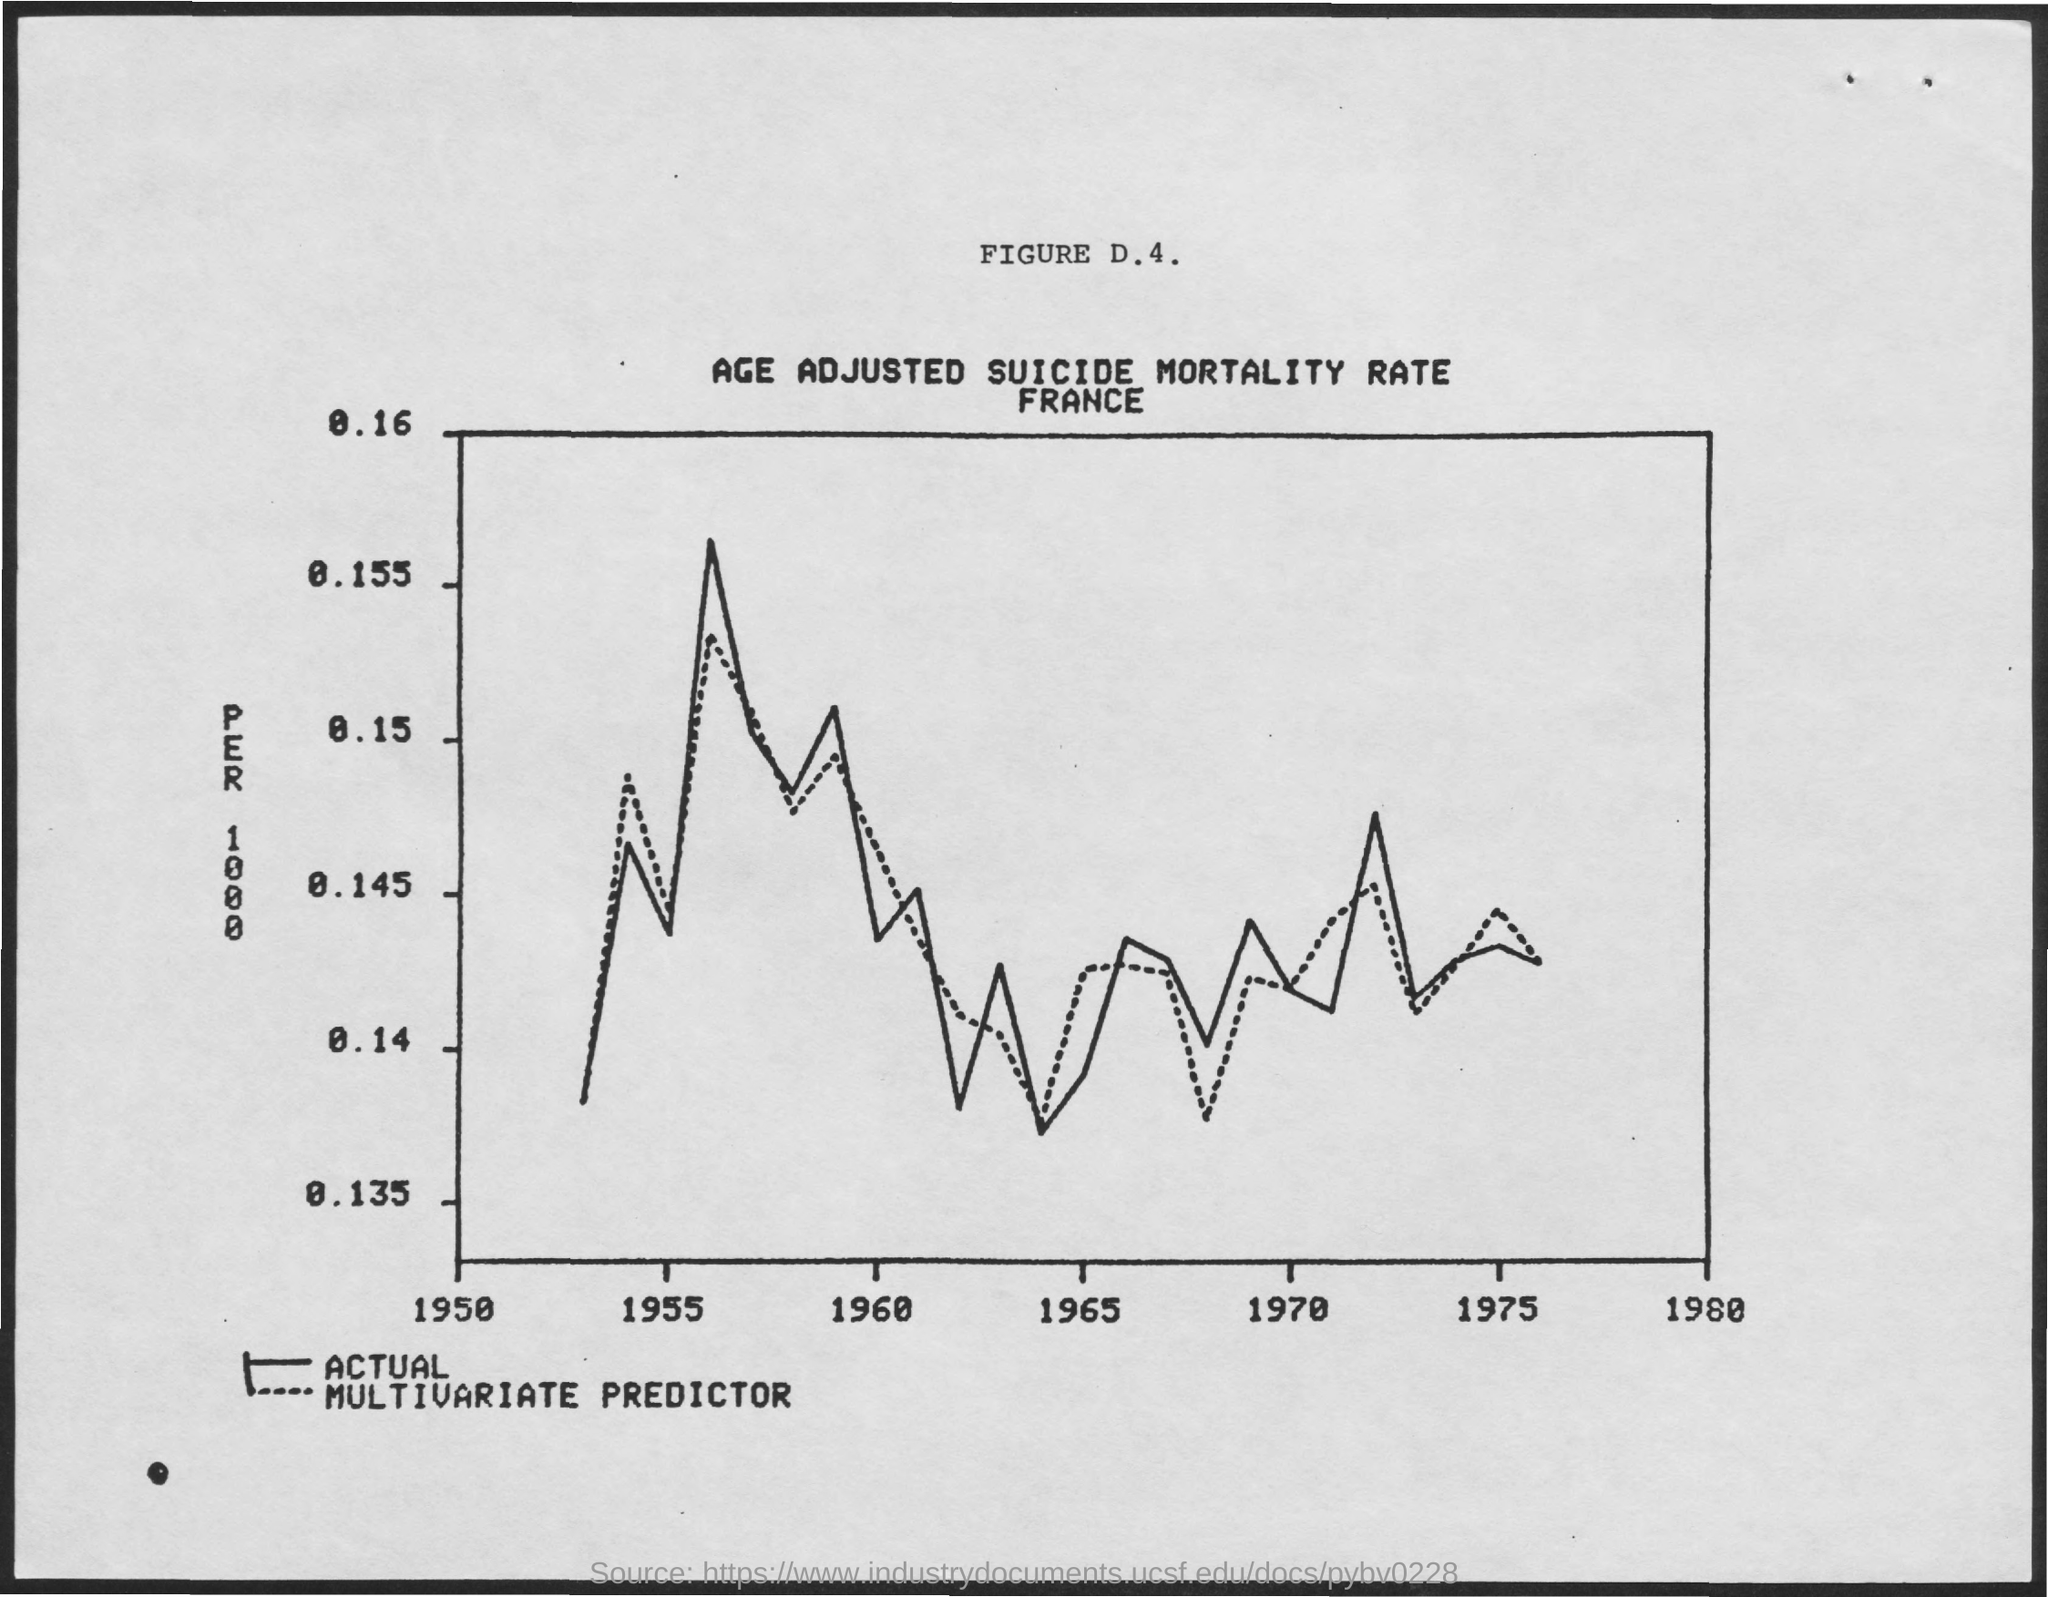List a handful of essential elements in this visual. The number of reported cases of tuberculosis per 1000 population is shown on the y-axis. The title for Figure D.4 is "Age-Adjusted Suicide Mortality Rate in France. The dotted curve in the graph represents a multivariate predictor that is used to predict the future performance of a system. 